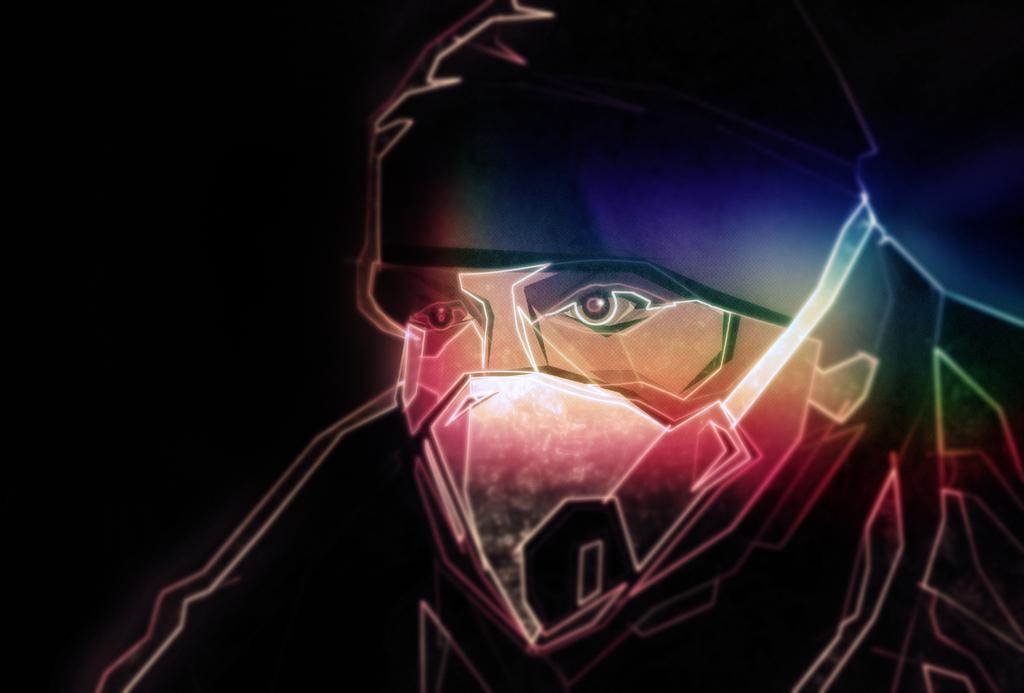What type of image is being described? The image is an animated picture. Can you describe the main subject in the image? There is a man in the image. What can be observed about the background of the image? The background of the image is dark. How many chickens are present in the image? There are no chickens present in the image; it features an animated man with a dark background. 